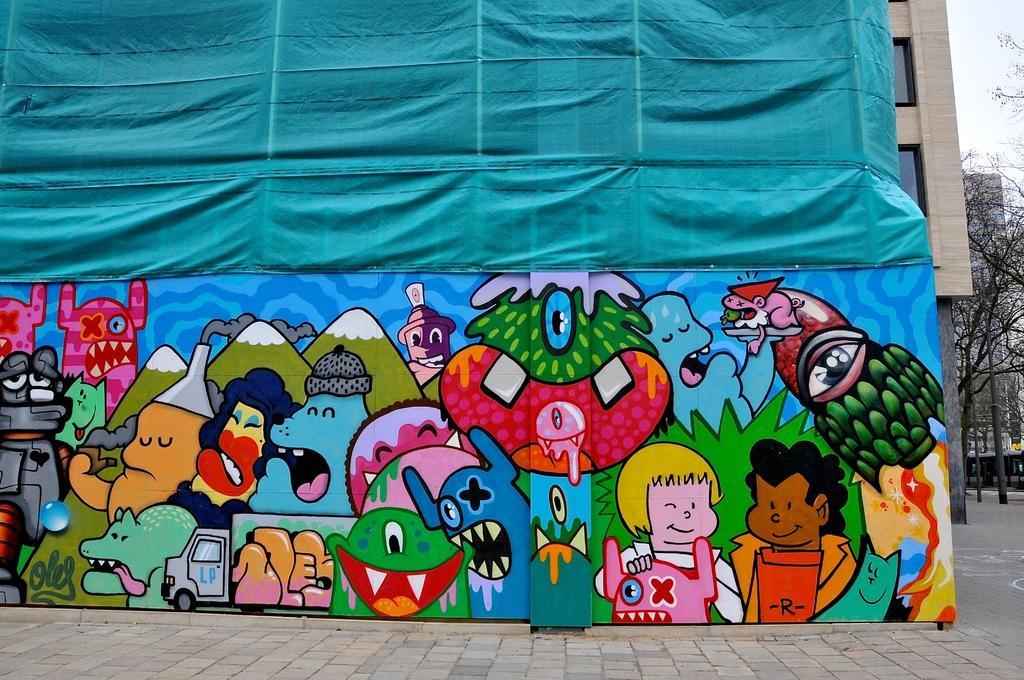Can you describe this image briefly? In this image we can see a wall with some pictures on it. We can also see a building with windows, a cloth, some trees, a pole and the sky. 